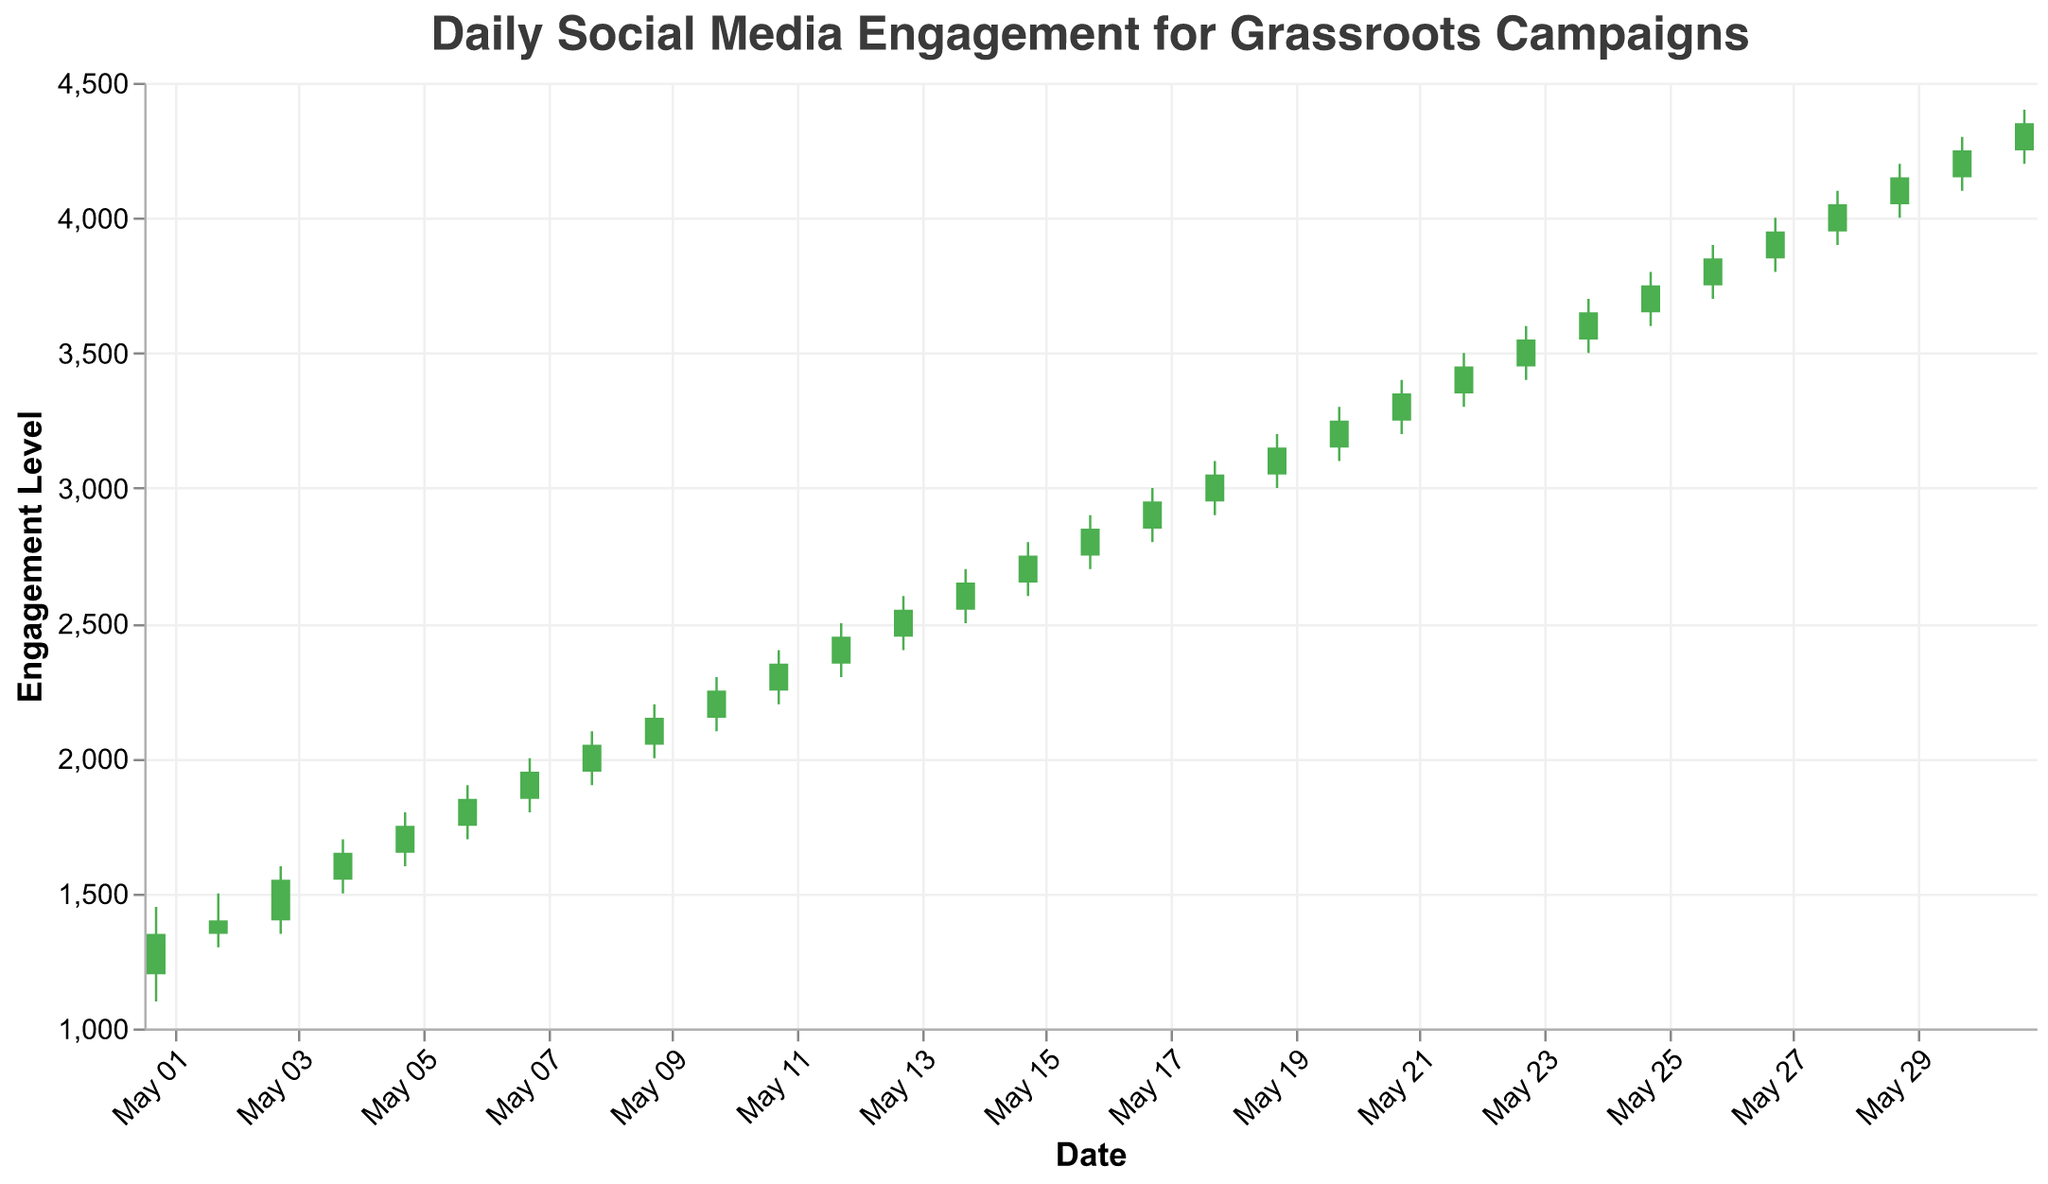What is the title of the figure? The title of the figure is displayed at the top and states the main focus is on daily social media engagement for grassroots campaigns over a month.
Answer: Daily Social Media Engagement for Grassroots Campaigns How many days of data are visualized in the chart? The x-axis represents days within the month of May, and each bar/rule combination corresponds to a single day. There are 31 days of data visualized.
Answer: 31 On which date did the social media engagement close at its highest level? By examining the Close values on the y-axis for each date, the highest Close value is on May 31st, with a Close of 4350.
Answer: May 31 What is the average engagement level for the first week of May (May 1 to May 7)? Add up the Close values for May 1 to May 7 and divide by 7: (1350 + 1400 + 1550 + 1650 + 1750 + 1850 + 1950) / 7 = 11500 / 7.
Answer: 1642.86 Which date saw the largest range of engagement? The range of engagement is calculated by subtracting the Low value from the High value for each date. The largest range is on May 28 with a High of 4100 and a Low of 3900, resulting in a range of 200.
Answer: May 28 Did social media engagement generally increase or decrease over the month? Observing the trend from the beginning (Close of 1350 on May 1) to the end (Close of 4350 on May 31) shows a general increasing trend.
Answer: Increase On which dates did the Close value become lower than the Open value? By checking the color of the bars, the bars that are red (indicating Close is lower than Open) appear on certain dates. For example, May 2 (1400 < 1350), May 3 (1550 < 1400), and so on. Calculate for each day to list all such dates.
Answer: None What is the median Close value for the month of May? To find the median, list all Close values in ascending order and find the middle number: 
(1350, 1400, 1550, 1650, 1750, 1850, 1950, 2050, 2150, 2250, 2350, 2450, 2550, 2650, 2750, 2850, 2950, 3050, 3150, 3250, 3350, 3450, 3550, 3650, 3750, 3850, 3950, 4050, 4150, 4250, 4350). 
Since there are 31 days, the median is the 16th value: 2850.
Answer: 2850 What was the lowest value of engagement and on which date did it occur? The Lowest value is determined by looking at the "Low" values for each date. The lowest value is 1100 on May 1.
Answer: 1100 on May 1 Which date had the largest single-day increase from Open to Close? The single-day increase is calculated by subtracting the Open value from the Close value. The largest increase occurred on May 31 (4350 - 4250 = 100).
Answer: May 31 